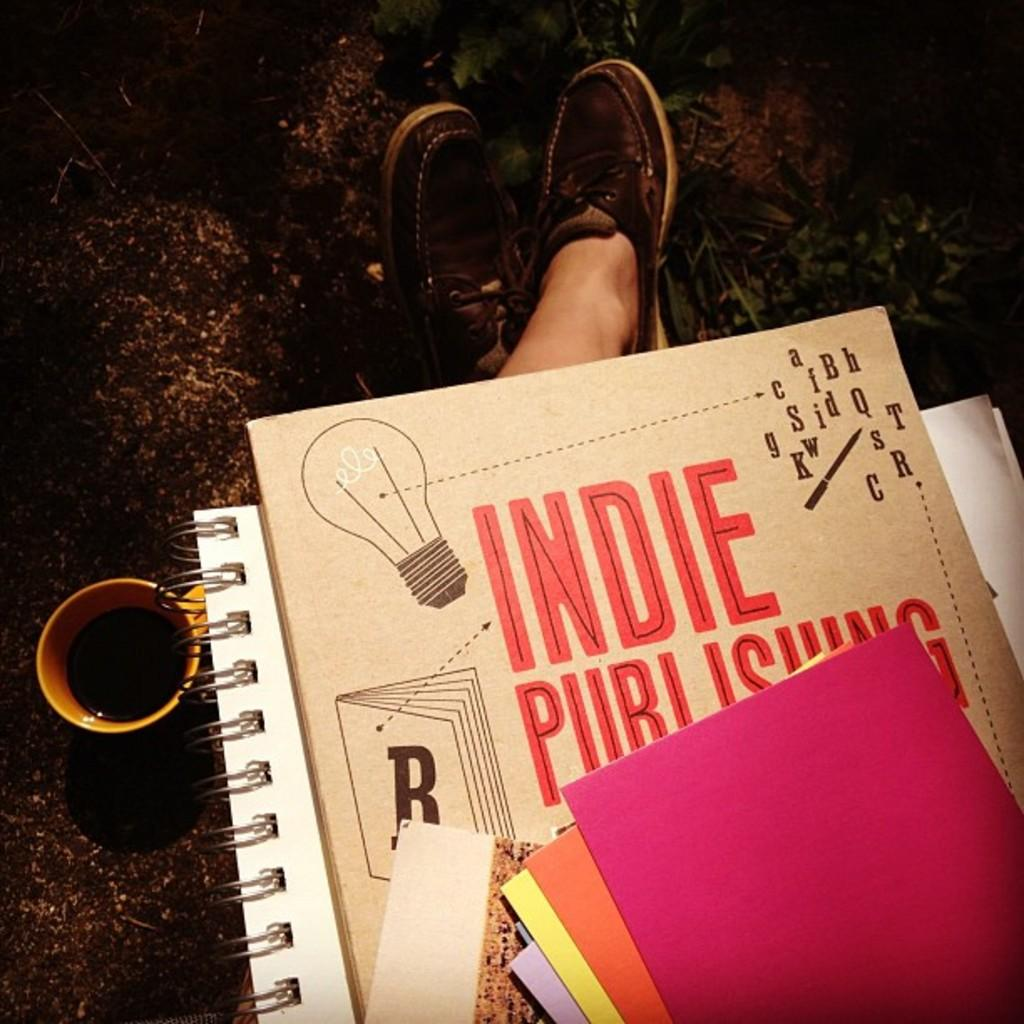<image>
Write a terse but informative summary of the picture. a view of someone's lap with notebooks and cards reading Indie Publishing 